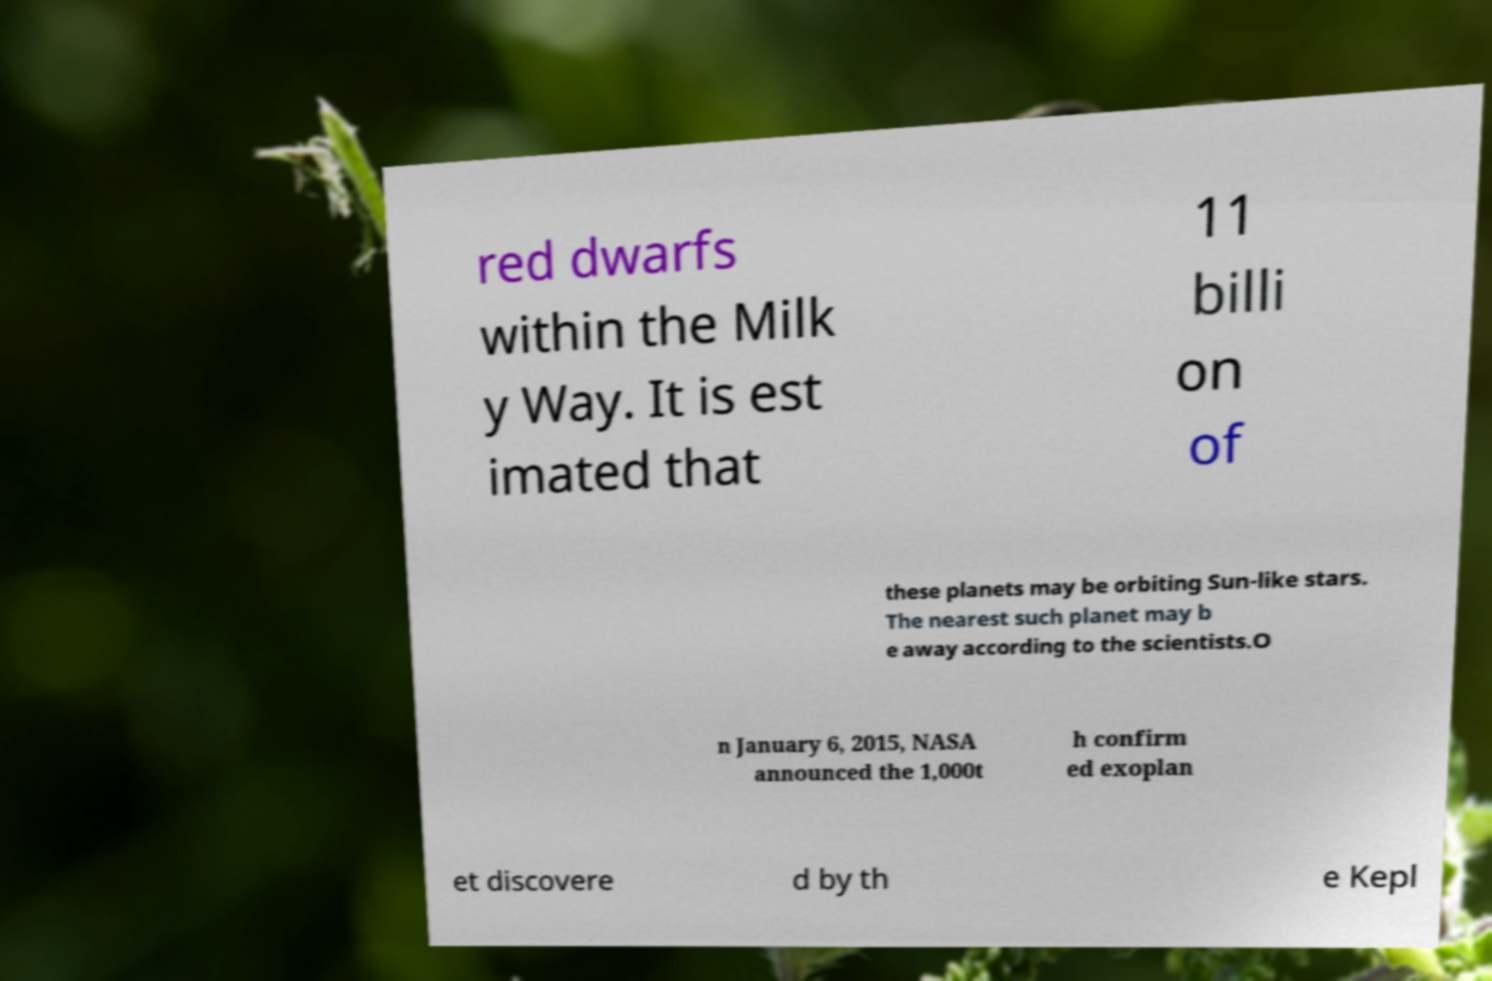I need the written content from this picture converted into text. Can you do that? red dwarfs within the Milk y Way. It is est imated that 11 billi on of these planets may be orbiting Sun-like stars. The nearest such planet may b e away according to the scientists.O n January 6, 2015, NASA announced the 1,000t h confirm ed exoplan et discovere d by th e Kepl 